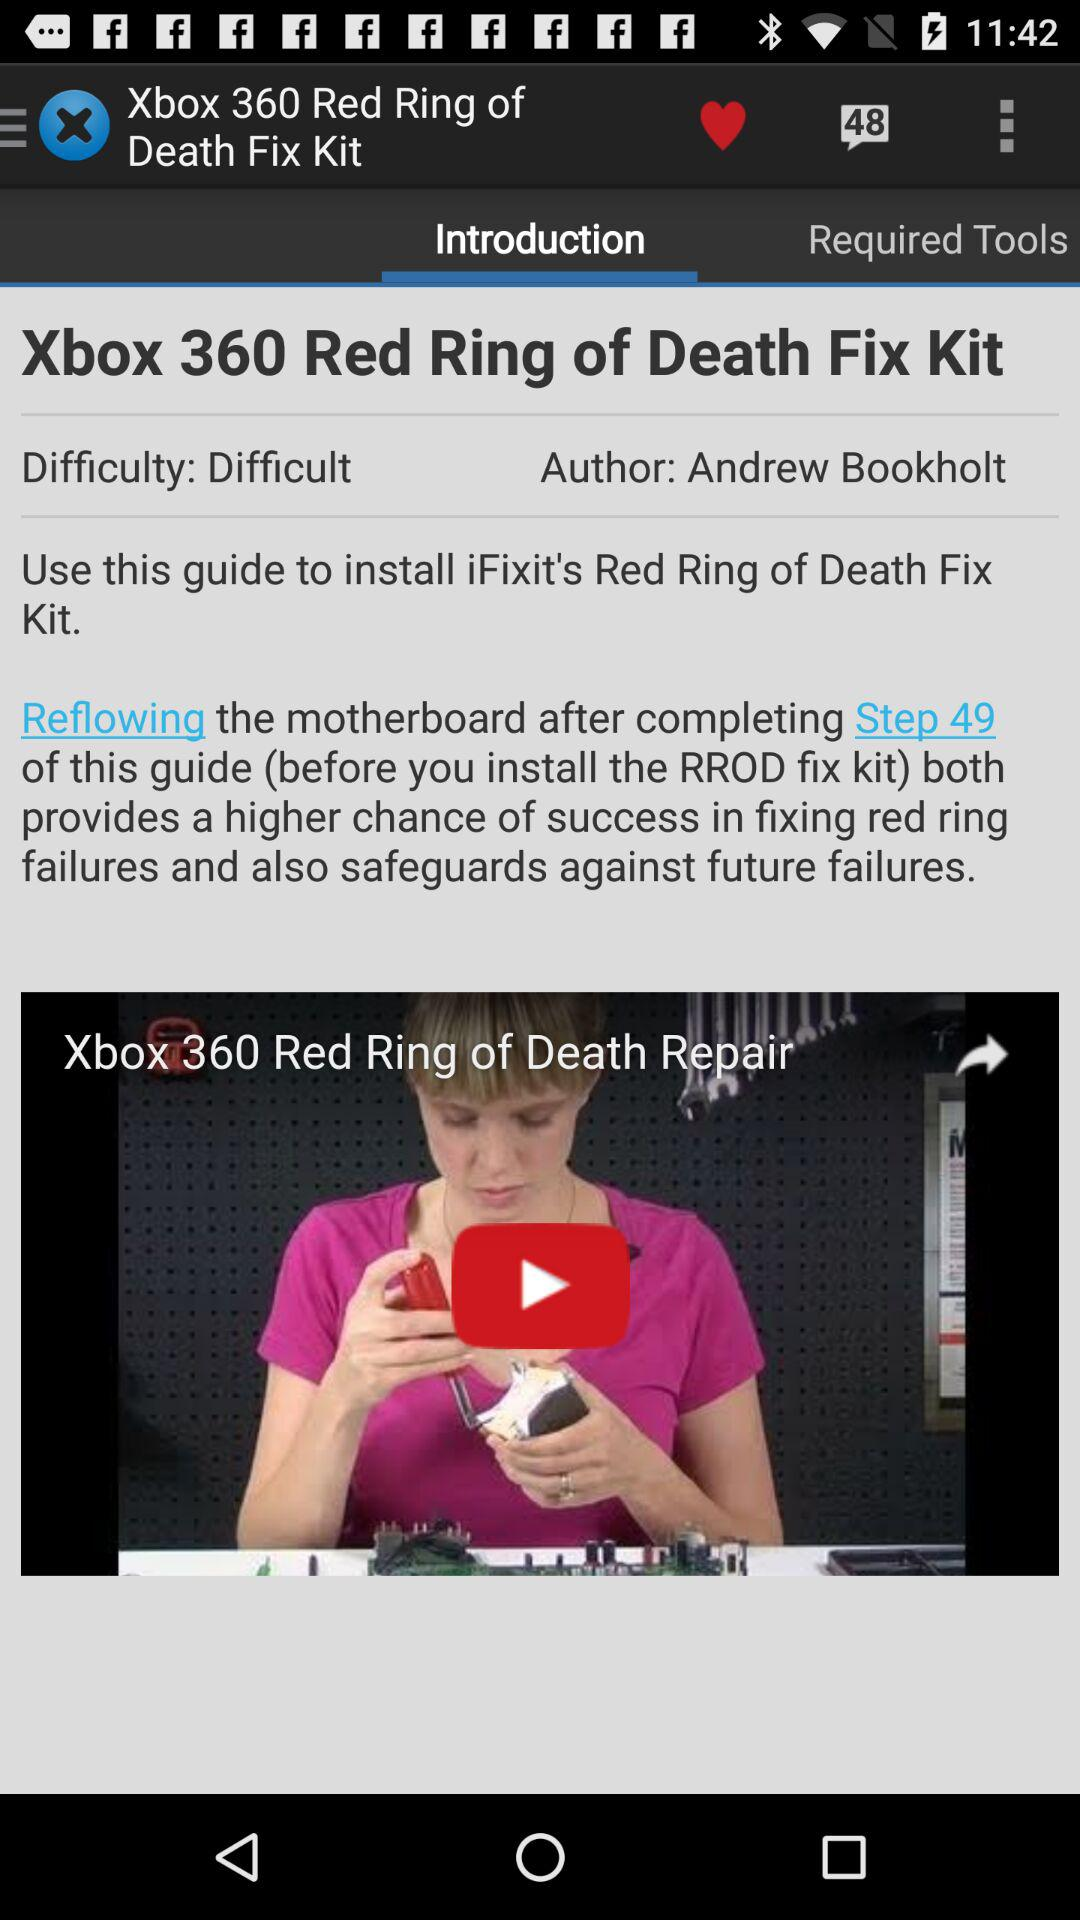Which tab is selected? The selected tab is "Introduction". 